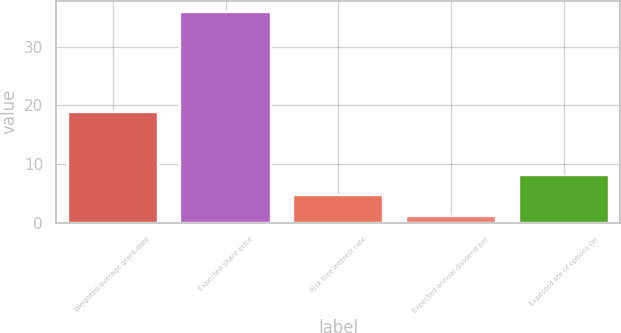Convert chart to OTSL. <chart><loc_0><loc_0><loc_500><loc_500><bar_chart><fcel>Weighted-average grant-date<fcel>Expected share price<fcel>Risk free interest rate<fcel>Expected annual dividend per<fcel>Expected life of options (in<nl><fcel>18.77<fcel>36<fcel>4.64<fcel>1.16<fcel>8.12<nl></chart> 